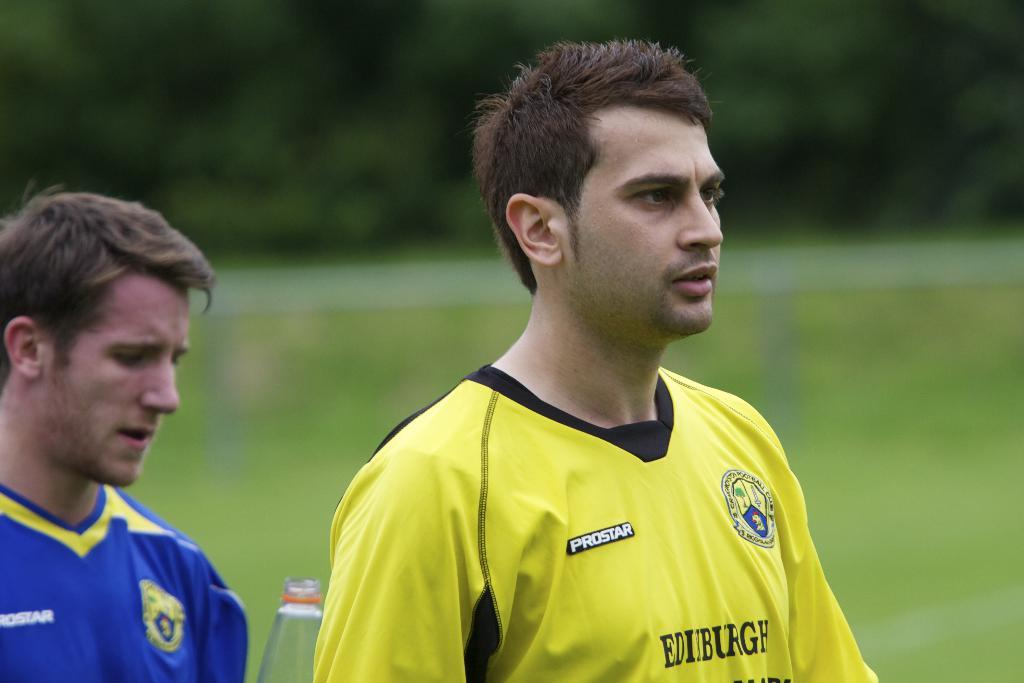<image>
Create a compact narrative representing the image presented. The player in yellow has a black tag that says Prostar on the front 